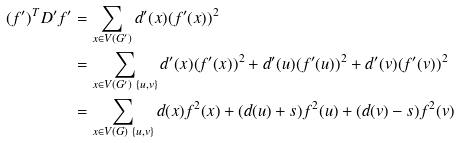Convert formula to latex. <formula><loc_0><loc_0><loc_500><loc_500>( f ^ { \prime } ) ^ { T } D ^ { \prime } f ^ { \prime } & = \sum _ { x \in V ( G ^ { \prime } ) } d ^ { \prime } ( x ) ( f ^ { \prime } ( x ) ) ^ { 2 } \\ & = \sum _ { x \in V ( G ^ { \prime } ) \ \{ u , v \} } d ^ { \prime } ( x ) ( f ^ { \prime } ( x ) ) ^ { 2 } + d ^ { \prime } ( u ) ( f ^ { \prime } ( u ) ) ^ { 2 } + d ^ { \prime } ( v ) ( f ^ { \prime } ( v ) ) ^ { 2 } \\ & = \sum _ { x \in V ( G ) \ \{ u , v \} } d ( x ) f ^ { 2 } ( x ) + ( d ( u ) + s ) f ^ { 2 } ( u ) + ( d ( v ) - s ) f ^ { 2 } ( v )</formula> 